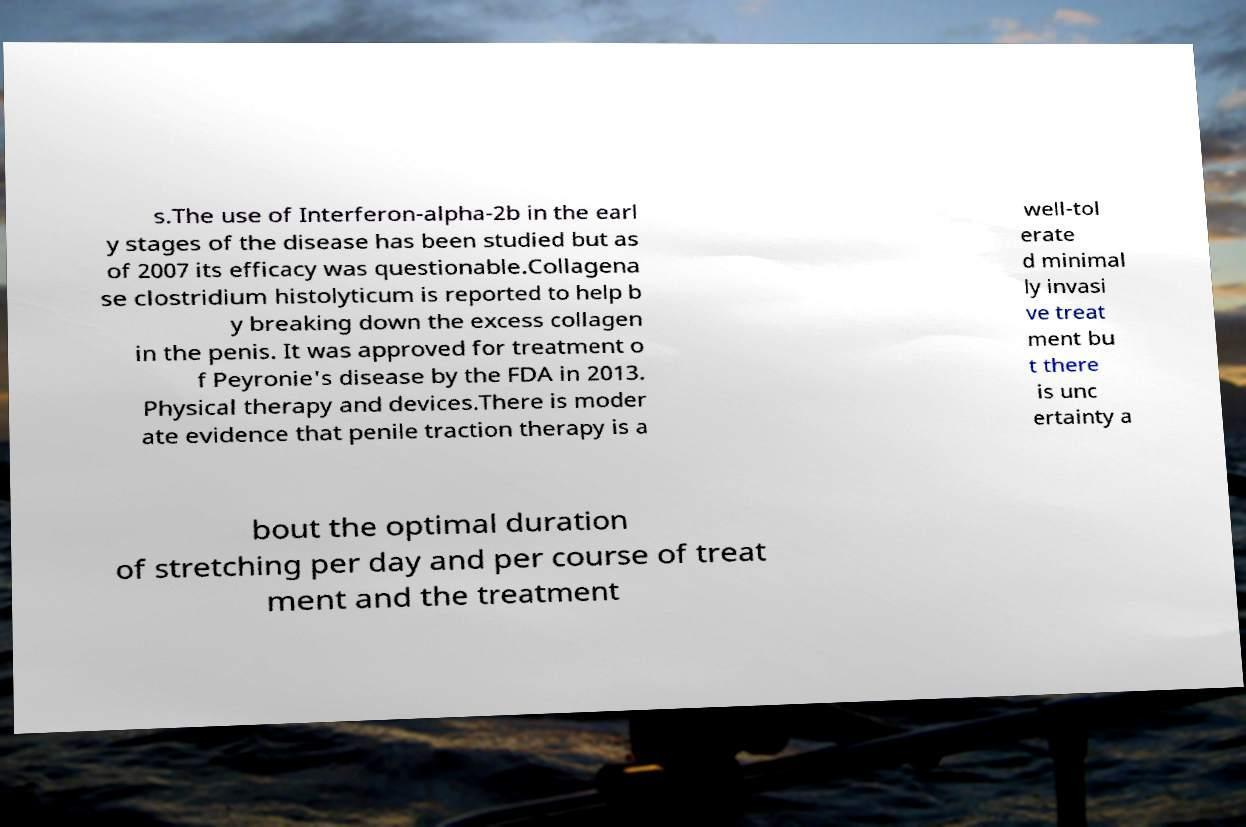What messages or text are displayed in this image? I need them in a readable, typed format. s.The use of Interferon-alpha-2b in the earl y stages of the disease has been studied but as of 2007 its efficacy was questionable.Collagena se clostridium histolyticum is reported to help b y breaking down the excess collagen in the penis. It was approved for treatment o f Peyronie's disease by the FDA in 2013. Physical therapy and devices.There is moder ate evidence that penile traction therapy is a well-tol erate d minimal ly invasi ve treat ment bu t there is unc ertainty a bout the optimal duration of stretching per day and per course of treat ment and the treatment 